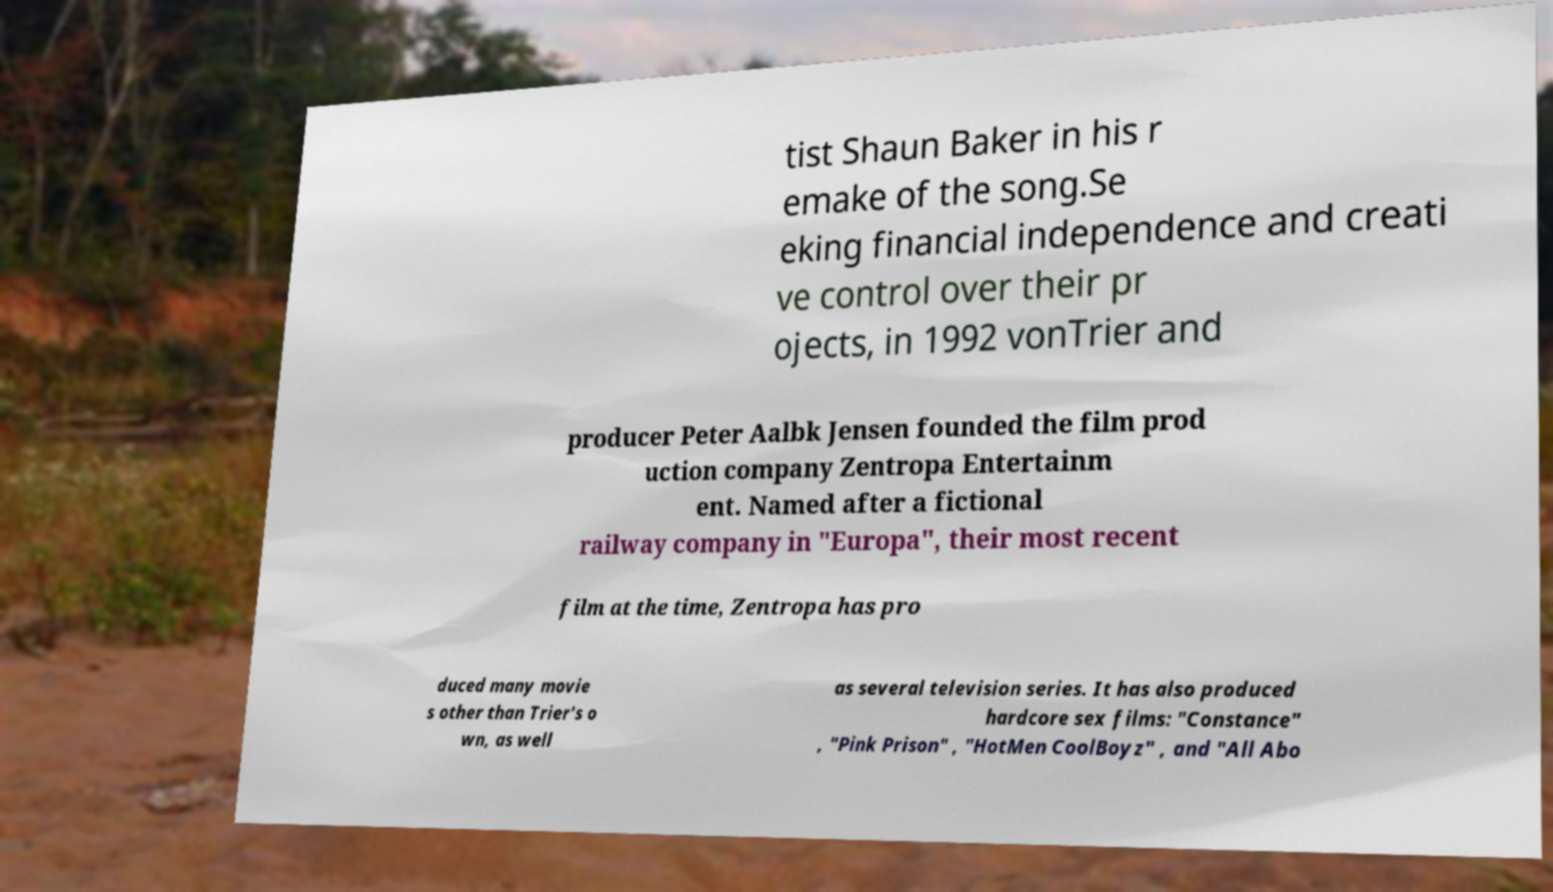Can you read and provide the text displayed in the image?This photo seems to have some interesting text. Can you extract and type it out for me? tist Shaun Baker in his r emake of the song.Se eking financial independence and creati ve control over their pr ojects, in 1992 vonTrier and producer Peter Aalbk Jensen founded the film prod uction company Zentropa Entertainm ent. Named after a fictional railway company in "Europa", their most recent film at the time, Zentropa has pro duced many movie s other than Trier's o wn, as well as several television series. It has also produced hardcore sex films: "Constance" , "Pink Prison" , "HotMen CoolBoyz" , and "All Abo 